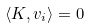<formula> <loc_0><loc_0><loc_500><loc_500>\langle K , v _ { i } \rangle = 0</formula> 